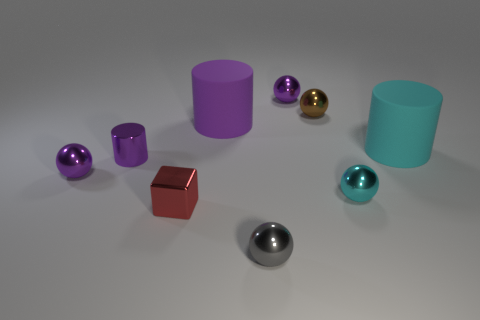Subtract all brown balls. How many balls are left? 4 Subtract 1 cylinders. How many cylinders are left? 2 Subtract all spheres. How many objects are left? 4 Subtract all gray balls. How many cyan cylinders are left? 1 Add 5 large cyan metallic cubes. How many large cyan metallic cubes exist? 5 Subtract all gray spheres. How many spheres are left? 4 Subtract 0 gray cylinders. How many objects are left? 9 Subtract all green blocks. Subtract all purple cylinders. How many blocks are left? 1 Subtract all large spheres. Subtract all large purple things. How many objects are left? 8 Add 1 big matte objects. How many big matte objects are left? 3 